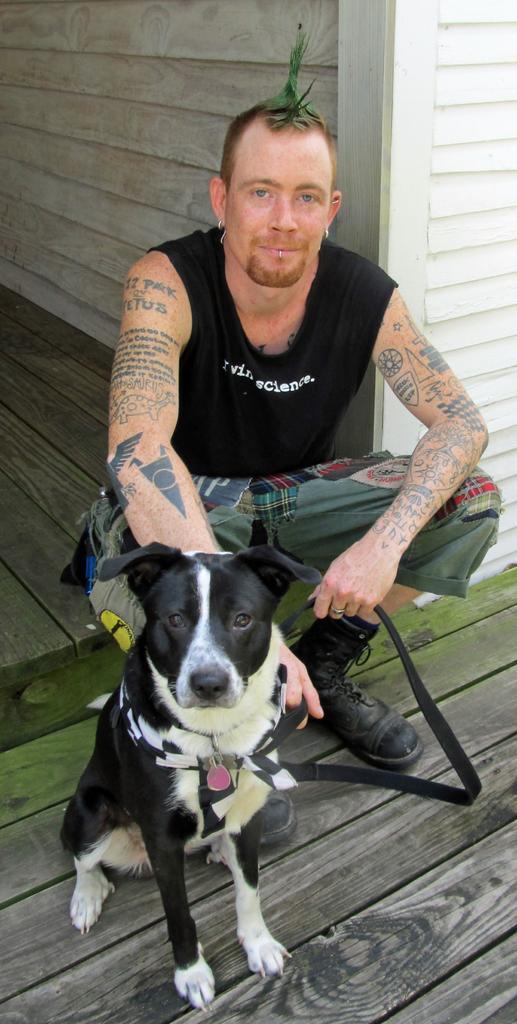In one or two sentences, can you explain what this image depicts? In this image there is a dog sitting and there is a man sitting. In the background there is a wooden wall. 